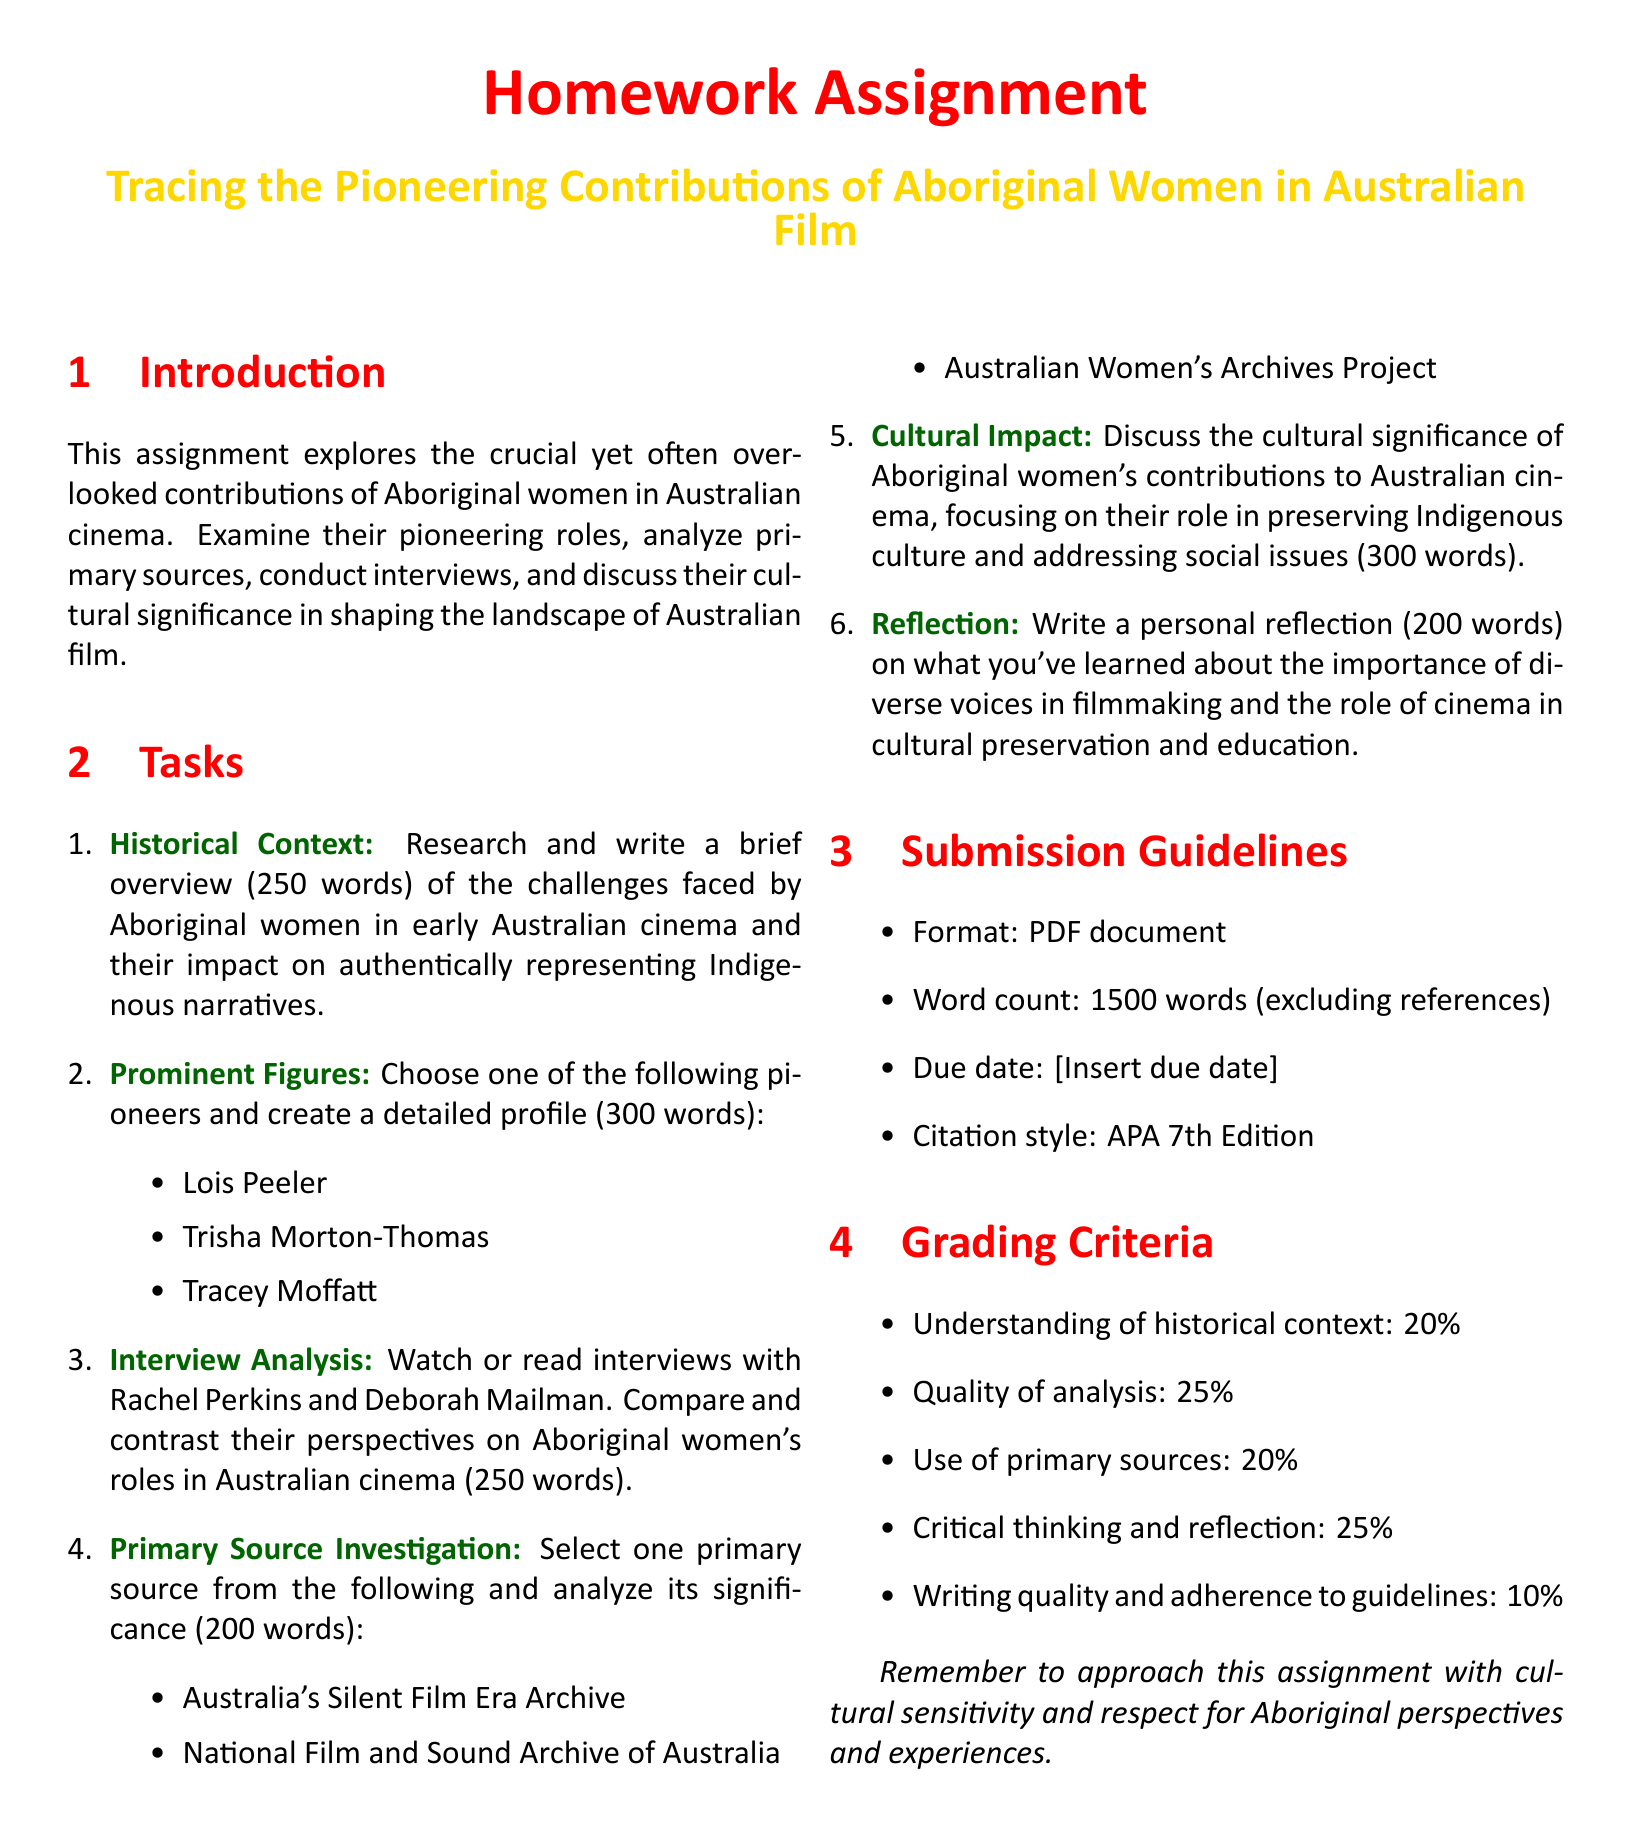What is the word count for the historical context overview? The document specifies that the historical context overview should be 250 words.
Answer: 250 words Who are the three prominent figures listed for the profile task? The prominent figures to choose from for the profile task are Lois Peeler, Trisha Morton-Thomas, and Tracey Moffatt.
Answer: Lois Peeler, Trisha Morton-Thomas, Tracey Moffatt What does the submission guidelines specify about the citation style? The citation style required in the submission guidelines is the APA 7th Edition.
Answer: APA 7th Edition How much of the grading criteria is dedicated to understanding historical context? The grading criteria allocates 20% for understanding historical context.
Answer: 20% What is one primary source option provided for investigation? The document lists three options for primary source investigation, one of which is the National Film and Sound Archive of Australia.
Answer: National Film and Sound Archive of Australia What is the total word count for the assignment, excluding references? The total word count specified in the submission guidelines, excluding references, is 1500 words.
Answer: 1500 words What is the maximum percentage for writing quality in the grading criteria? The maximum percentage allocated for writing quality in the grading criteria is 10%.
Answer: 10% Which task requires a personal reflection and how many words is it? The task for personal reflection requires a writing of 200 words.
Answer: 200 words 